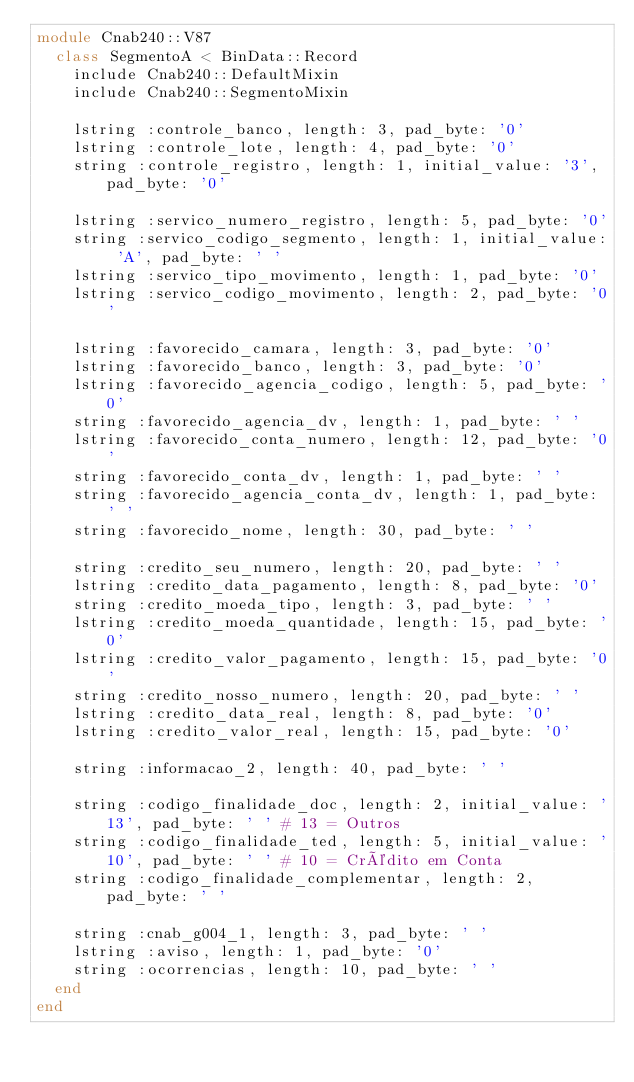Convert code to text. <code><loc_0><loc_0><loc_500><loc_500><_Ruby_>module Cnab240::V87
  class SegmentoA < BinData::Record
    include Cnab240::DefaultMixin
    include Cnab240::SegmentoMixin

    lstring :controle_banco, length: 3, pad_byte: '0'
    lstring :controle_lote, length: 4, pad_byte: '0'
    string :controle_registro, length: 1, initial_value: '3', pad_byte: '0'

    lstring :servico_numero_registro, length: 5, pad_byte: '0'
    string :servico_codigo_segmento, length: 1, initial_value: 'A', pad_byte: ' '
    lstring :servico_tipo_movimento, length: 1, pad_byte: '0'
    lstring :servico_codigo_movimento, length: 2, pad_byte: '0'

    lstring :favorecido_camara, length: 3, pad_byte: '0'
    lstring :favorecido_banco, length: 3, pad_byte: '0'
    lstring :favorecido_agencia_codigo, length: 5, pad_byte: '0'
    string :favorecido_agencia_dv, length: 1, pad_byte: ' '
    lstring :favorecido_conta_numero, length: 12, pad_byte: '0'
    string :favorecido_conta_dv, length: 1, pad_byte: ' '
    string :favorecido_agencia_conta_dv, length: 1, pad_byte: ' '
    string :favorecido_nome, length: 30, pad_byte: ' '

    string :credito_seu_numero, length: 20, pad_byte: ' '
    lstring :credito_data_pagamento, length: 8, pad_byte: '0'
    string :credito_moeda_tipo, length: 3, pad_byte: ' '
    lstring :credito_moeda_quantidade, length: 15, pad_byte: '0'
    lstring :credito_valor_pagamento, length: 15, pad_byte: '0'
    string :credito_nosso_numero, length: 20, pad_byte: ' '
    lstring :credito_data_real, length: 8, pad_byte: '0'
    lstring :credito_valor_real, length: 15, pad_byte: '0'

    string :informacao_2, length: 40, pad_byte: ' '

    string :codigo_finalidade_doc, length: 2, initial_value: '13', pad_byte: ' ' # 13 = Outros
    string :codigo_finalidade_ted, length: 5, initial_value: '10', pad_byte: ' ' # 10 = Crédito em Conta
    string :codigo_finalidade_complementar, length: 2, pad_byte: ' '

    string :cnab_g004_1, length: 3, pad_byte: ' '
    lstring :aviso, length: 1, pad_byte: '0'
    string :ocorrencias, length: 10, pad_byte: ' '
  end
end
</code> 